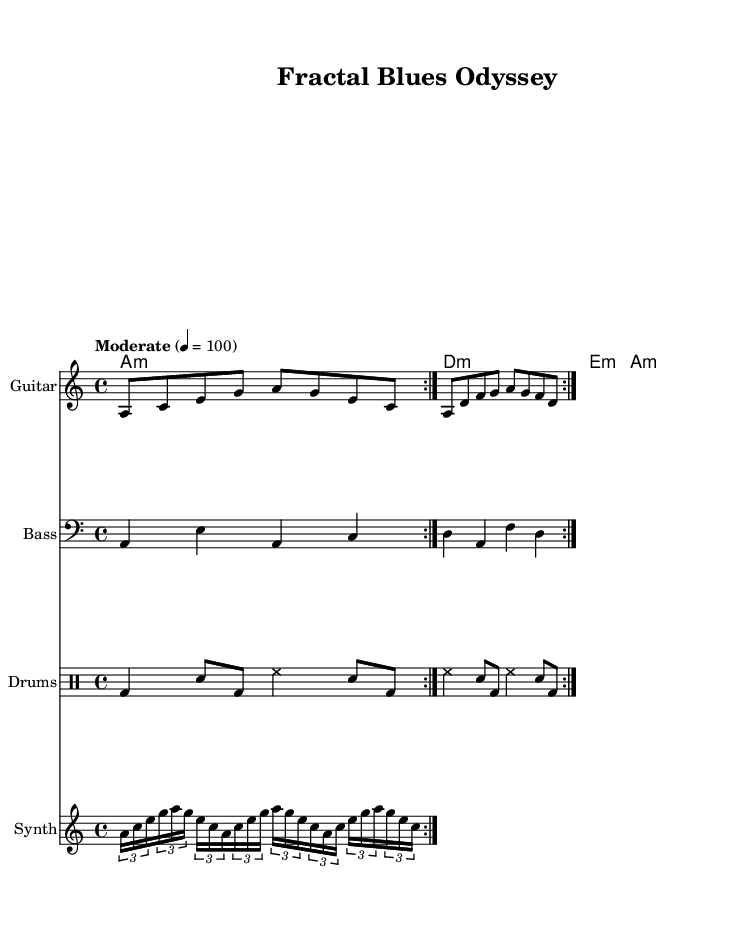What is the key signature of this music? The key signature is indicated at the beginning of the staff, which shows there are no sharps or flats, hence it is A minor.
Answer: A minor What is the time signature of this music? The time signature appears at the beginning, showing a 4/4 pattern, which means there are four beats per measure.
Answer: 4/4 What is the tempo marking for this piece? The tempo marking is indicated as "Moderate" with a metronome marking of 4 = 100, suggesting a moderate pace.
Answer: Moderate 4 = 100 How many measures are there in the guitar part? The guitar part consists of two repeated sections (volta), and each section has two measures. Thus, there are 4 measures total.
Answer: 4 What is the bass note played first? The bass part starts with an "A" in the first measure when played.
Answer: A Which instrument plays the synth music? The staff labeled "Synth" contains the notes specifically notated for synthesizer, which identifies that this instrument plays the synth music.
Answer: Synth What is the rhythmic pattern used in the drums? Analyzing the drum part, it features a consistent pattern of bass drum, snare, and hi-hat in a particular sequence throughout its repetitions.
Answer: Bass, snare, hi-hat 